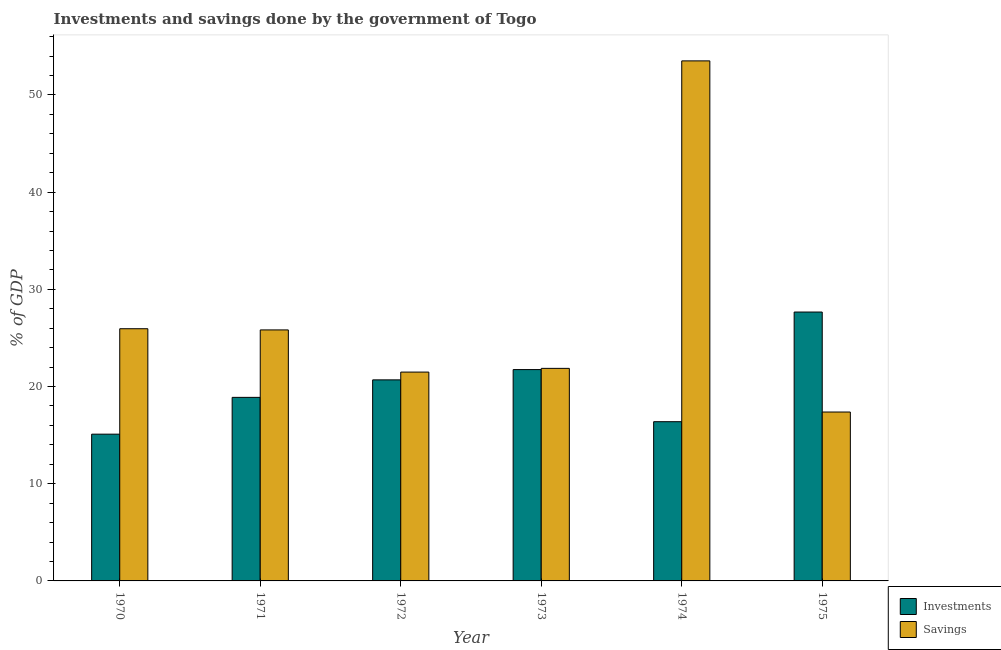How many different coloured bars are there?
Give a very brief answer. 2. Are the number of bars on each tick of the X-axis equal?
Your response must be concise. Yes. How many bars are there on the 4th tick from the left?
Provide a short and direct response. 2. How many bars are there on the 2nd tick from the right?
Ensure brevity in your answer.  2. In how many cases, is the number of bars for a given year not equal to the number of legend labels?
Provide a short and direct response. 0. What is the savings of government in 1971?
Make the answer very short. 25.83. Across all years, what is the maximum investments of government?
Your response must be concise. 27.66. Across all years, what is the minimum savings of government?
Keep it short and to the point. 17.38. In which year was the savings of government maximum?
Provide a succinct answer. 1974. In which year was the savings of government minimum?
Keep it short and to the point. 1975. What is the total savings of government in the graph?
Provide a short and direct response. 166.01. What is the difference between the savings of government in 1972 and that in 1973?
Your answer should be compact. -0.38. What is the difference between the investments of government in 1973 and the savings of government in 1975?
Your answer should be compact. -5.92. What is the average savings of government per year?
Your answer should be very brief. 27.67. In the year 1971, what is the difference between the savings of government and investments of government?
Keep it short and to the point. 0. In how many years, is the investments of government greater than 6 %?
Offer a terse response. 6. What is the ratio of the savings of government in 1971 to that in 1972?
Give a very brief answer. 1.2. Is the savings of government in 1972 less than that in 1974?
Provide a succinct answer. Yes. Is the difference between the investments of government in 1970 and 1974 greater than the difference between the savings of government in 1970 and 1974?
Offer a terse response. No. What is the difference between the highest and the second highest investments of government?
Keep it short and to the point. 5.92. What is the difference between the highest and the lowest savings of government?
Provide a short and direct response. 36.13. Is the sum of the savings of government in 1972 and 1975 greater than the maximum investments of government across all years?
Your response must be concise. No. What does the 2nd bar from the left in 1974 represents?
Make the answer very short. Savings. What does the 2nd bar from the right in 1971 represents?
Your response must be concise. Investments. How many bars are there?
Ensure brevity in your answer.  12. How many years are there in the graph?
Provide a short and direct response. 6. What is the difference between two consecutive major ticks on the Y-axis?
Make the answer very short. 10. Are the values on the major ticks of Y-axis written in scientific E-notation?
Keep it short and to the point. No. Does the graph contain grids?
Offer a very short reply. No. How many legend labels are there?
Your response must be concise. 2. How are the legend labels stacked?
Offer a terse response. Vertical. What is the title of the graph?
Provide a succinct answer. Investments and savings done by the government of Togo. What is the label or title of the Y-axis?
Offer a terse response. % of GDP. What is the % of GDP of Investments in 1970?
Provide a short and direct response. 15.1. What is the % of GDP in Savings in 1970?
Make the answer very short. 25.95. What is the % of GDP in Investments in 1971?
Your response must be concise. 18.88. What is the % of GDP of Savings in 1971?
Keep it short and to the point. 25.83. What is the % of GDP in Investments in 1972?
Give a very brief answer. 20.69. What is the % of GDP of Savings in 1972?
Offer a very short reply. 21.49. What is the % of GDP of Investments in 1973?
Offer a terse response. 21.74. What is the % of GDP of Savings in 1973?
Your response must be concise. 21.87. What is the % of GDP of Investments in 1974?
Your response must be concise. 16.38. What is the % of GDP in Savings in 1974?
Offer a terse response. 53.5. What is the % of GDP in Investments in 1975?
Your answer should be compact. 27.66. What is the % of GDP of Savings in 1975?
Make the answer very short. 17.38. Across all years, what is the maximum % of GDP of Investments?
Ensure brevity in your answer.  27.66. Across all years, what is the maximum % of GDP in Savings?
Offer a terse response. 53.5. Across all years, what is the minimum % of GDP of Investments?
Provide a succinct answer. 15.1. Across all years, what is the minimum % of GDP in Savings?
Provide a succinct answer. 17.38. What is the total % of GDP in Investments in the graph?
Your answer should be very brief. 120.46. What is the total % of GDP of Savings in the graph?
Offer a terse response. 166.01. What is the difference between the % of GDP in Investments in 1970 and that in 1971?
Your answer should be compact. -3.78. What is the difference between the % of GDP of Savings in 1970 and that in 1971?
Offer a terse response. 0.12. What is the difference between the % of GDP of Investments in 1970 and that in 1972?
Your answer should be compact. -5.59. What is the difference between the % of GDP in Savings in 1970 and that in 1972?
Keep it short and to the point. 4.46. What is the difference between the % of GDP of Investments in 1970 and that in 1973?
Provide a short and direct response. -6.64. What is the difference between the % of GDP in Savings in 1970 and that in 1973?
Provide a succinct answer. 4.08. What is the difference between the % of GDP of Investments in 1970 and that in 1974?
Offer a terse response. -1.28. What is the difference between the % of GDP of Savings in 1970 and that in 1974?
Give a very brief answer. -27.56. What is the difference between the % of GDP in Investments in 1970 and that in 1975?
Your answer should be compact. -12.56. What is the difference between the % of GDP of Savings in 1970 and that in 1975?
Offer a very short reply. 8.57. What is the difference between the % of GDP in Investments in 1971 and that in 1972?
Give a very brief answer. -1.8. What is the difference between the % of GDP in Savings in 1971 and that in 1972?
Your answer should be compact. 4.34. What is the difference between the % of GDP in Investments in 1971 and that in 1973?
Provide a short and direct response. -2.86. What is the difference between the % of GDP of Savings in 1971 and that in 1973?
Your answer should be compact. 3.96. What is the difference between the % of GDP in Investments in 1971 and that in 1974?
Keep it short and to the point. 2.5. What is the difference between the % of GDP in Savings in 1971 and that in 1974?
Offer a very short reply. -27.68. What is the difference between the % of GDP of Investments in 1971 and that in 1975?
Give a very brief answer. -8.78. What is the difference between the % of GDP of Savings in 1971 and that in 1975?
Ensure brevity in your answer.  8.45. What is the difference between the % of GDP of Investments in 1972 and that in 1973?
Offer a very short reply. -1.06. What is the difference between the % of GDP of Savings in 1972 and that in 1973?
Offer a very short reply. -0.38. What is the difference between the % of GDP in Investments in 1972 and that in 1974?
Keep it short and to the point. 4.3. What is the difference between the % of GDP of Savings in 1972 and that in 1974?
Your answer should be very brief. -32.02. What is the difference between the % of GDP of Investments in 1972 and that in 1975?
Provide a succinct answer. -6.98. What is the difference between the % of GDP of Savings in 1972 and that in 1975?
Ensure brevity in your answer.  4.11. What is the difference between the % of GDP of Investments in 1973 and that in 1974?
Ensure brevity in your answer.  5.36. What is the difference between the % of GDP of Savings in 1973 and that in 1974?
Keep it short and to the point. -31.64. What is the difference between the % of GDP of Investments in 1973 and that in 1975?
Ensure brevity in your answer.  -5.92. What is the difference between the % of GDP in Savings in 1973 and that in 1975?
Keep it short and to the point. 4.49. What is the difference between the % of GDP of Investments in 1974 and that in 1975?
Keep it short and to the point. -11.28. What is the difference between the % of GDP in Savings in 1974 and that in 1975?
Provide a succinct answer. 36.13. What is the difference between the % of GDP in Investments in 1970 and the % of GDP in Savings in 1971?
Offer a terse response. -10.73. What is the difference between the % of GDP of Investments in 1970 and the % of GDP of Savings in 1972?
Make the answer very short. -6.39. What is the difference between the % of GDP of Investments in 1970 and the % of GDP of Savings in 1973?
Your answer should be very brief. -6.77. What is the difference between the % of GDP in Investments in 1970 and the % of GDP in Savings in 1974?
Your answer should be compact. -38.41. What is the difference between the % of GDP in Investments in 1970 and the % of GDP in Savings in 1975?
Provide a short and direct response. -2.28. What is the difference between the % of GDP of Investments in 1971 and the % of GDP of Savings in 1972?
Provide a succinct answer. -2.6. What is the difference between the % of GDP in Investments in 1971 and the % of GDP in Savings in 1973?
Your answer should be very brief. -2.98. What is the difference between the % of GDP of Investments in 1971 and the % of GDP of Savings in 1974?
Make the answer very short. -34.62. What is the difference between the % of GDP of Investments in 1971 and the % of GDP of Savings in 1975?
Offer a terse response. 1.51. What is the difference between the % of GDP in Investments in 1972 and the % of GDP in Savings in 1973?
Provide a short and direct response. -1.18. What is the difference between the % of GDP of Investments in 1972 and the % of GDP of Savings in 1974?
Offer a terse response. -32.82. What is the difference between the % of GDP of Investments in 1972 and the % of GDP of Savings in 1975?
Make the answer very short. 3.31. What is the difference between the % of GDP in Investments in 1973 and the % of GDP in Savings in 1974?
Your answer should be very brief. -31.76. What is the difference between the % of GDP in Investments in 1973 and the % of GDP in Savings in 1975?
Give a very brief answer. 4.37. What is the difference between the % of GDP of Investments in 1974 and the % of GDP of Savings in 1975?
Offer a very short reply. -0.99. What is the average % of GDP in Investments per year?
Ensure brevity in your answer.  20.08. What is the average % of GDP in Savings per year?
Ensure brevity in your answer.  27.67. In the year 1970, what is the difference between the % of GDP of Investments and % of GDP of Savings?
Give a very brief answer. -10.85. In the year 1971, what is the difference between the % of GDP of Investments and % of GDP of Savings?
Offer a terse response. -6.94. In the year 1972, what is the difference between the % of GDP of Investments and % of GDP of Savings?
Make the answer very short. -0.8. In the year 1973, what is the difference between the % of GDP in Investments and % of GDP in Savings?
Make the answer very short. -0.12. In the year 1974, what is the difference between the % of GDP in Investments and % of GDP in Savings?
Give a very brief answer. -37.12. In the year 1975, what is the difference between the % of GDP of Investments and % of GDP of Savings?
Your response must be concise. 10.29. What is the ratio of the % of GDP of Investments in 1970 to that in 1971?
Provide a short and direct response. 0.8. What is the ratio of the % of GDP in Investments in 1970 to that in 1972?
Make the answer very short. 0.73. What is the ratio of the % of GDP in Savings in 1970 to that in 1972?
Keep it short and to the point. 1.21. What is the ratio of the % of GDP in Investments in 1970 to that in 1973?
Provide a succinct answer. 0.69. What is the ratio of the % of GDP in Savings in 1970 to that in 1973?
Make the answer very short. 1.19. What is the ratio of the % of GDP of Investments in 1970 to that in 1974?
Your response must be concise. 0.92. What is the ratio of the % of GDP of Savings in 1970 to that in 1974?
Your answer should be very brief. 0.48. What is the ratio of the % of GDP of Investments in 1970 to that in 1975?
Ensure brevity in your answer.  0.55. What is the ratio of the % of GDP of Savings in 1970 to that in 1975?
Offer a very short reply. 1.49. What is the ratio of the % of GDP in Investments in 1971 to that in 1972?
Your answer should be very brief. 0.91. What is the ratio of the % of GDP in Savings in 1971 to that in 1972?
Provide a short and direct response. 1.2. What is the ratio of the % of GDP of Investments in 1971 to that in 1973?
Ensure brevity in your answer.  0.87. What is the ratio of the % of GDP of Savings in 1971 to that in 1973?
Provide a succinct answer. 1.18. What is the ratio of the % of GDP of Investments in 1971 to that in 1974?
Provide a short and direct response. 1.15. What is the ratio of the % of GDP in Savings in 1971 to that in 1974?
Offer a terse response. 0.48. What is the ratio of the % of GDP of Investments in 1971 to that in 1975?
Your response must be concise. 0.68. What is the ratio of the % of GDP of Savings in 1971 to that in 1975?
Ensure brevity in your answer.  1.49. What is the ratio of the % of GDP in Investments in 1972 to that in 1973?
Give a very brief answer. 0.95. What is the ratio of the % of GDP of Savings in 1972 to that in 1973?
Your answer should be very brief. 0.98. What is the ratio of the % of GDP in Investments in 1972 to that in 1974?
Give a very brief answer. 1.26. What is the ratio of the % of GDP of Savings in 1972 to that in 1974?
Ensure brevity in your answer.  0.4. What is the ratio of the % of GDP of Investments in 1972 to that in 1975?
Provide a short and direct response. 0.75. What is the ratio of the % of GDP of Savings in 1972 to that in 1975?
Your answer should be compact. 1.24. What is the ratio of the % of GDP in Investments in 1973 to that in 1974?
Provide a succinct answer. 1.33. What is the ratio of the % of GDP in Savings in 1973 to that in 1974?
Offer a terse response. 0.41. What is the ratio of the % of GDP of Investments in 1973 to that in 1975?
Provide a short and direct response. 0.79. What is the ratio of the % of GDP in Savings in 1973 to that in 1975?
Your response must be concise. 1.26. What is the ratio of the % of GDP of Investments in 1974 to that in 1975?
Your response must be concise. 0.59. What is the ratio of the % of GDP of Savings in 1974 to that in 1975?
Provide a short and direct response. 3.08. What is the difference between the highest and the second highest % of GDP of Investments?
Your response must be concise. 5.92. What is the difference between the highest and the second highest % of GDP of Savings?
Make the answer very short. 27.56. What is the difference between the highest and the lowest % of GDP in Investments?
Ensure brevity in your answer.  12.56. What is the difference between the highest and the lowest % of GDP of Savings?
Offer a terse response. 36.13. 